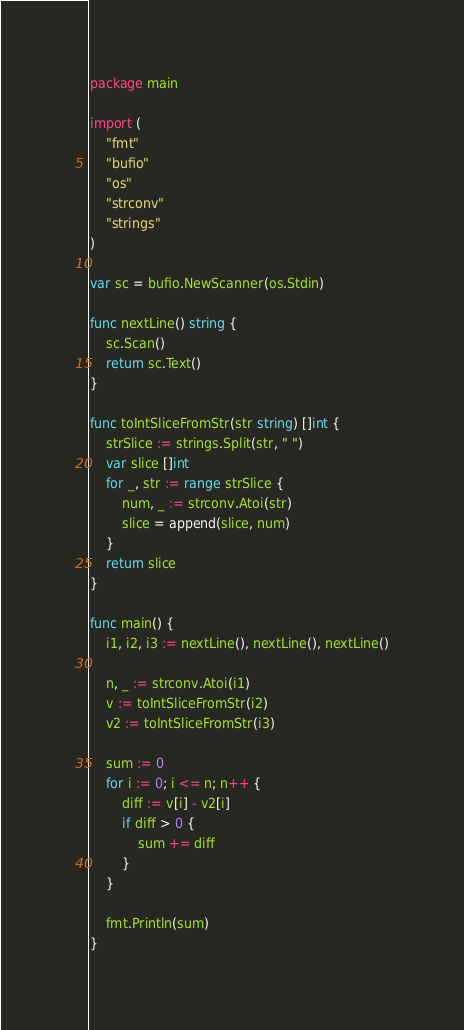Convert code to text. <code><loc_0><loc_0><loc_500><loc_500><_Go_>package main

import (
	"fmt"
	"bufio"
	"os"
	"strconv"
	"strings"
)

var sc = bufio.NewScanner(os.Stdin)

func nextLine() string {
	sc.Scan()
	return sc.Text()
}

func toIntSliceFromStr(str string) []int {
	strSlice := strings.Split(str, " ")
	var slice []int
	for _, str := range strSlice {
		num, _ := strconv.Atoi(str)
		slice = append(slice, num)
	}
	return slice
}

func main() {
	i1, i2, i3 := nextLine(), nextLine(), nextLine()

	n, _ := strconv.Atoi(i1)
	v := toIntSliceFromStr(i2)
	v2 := toIntSliceFromStr(i3)

	sum := 0
	for i := 0; i <= n; n++ {
		diff := v[i] - v2[i]
		if diff > 0 {
			sum += diff
		}
	}

	fmt.Println(sum)
}
</code> 